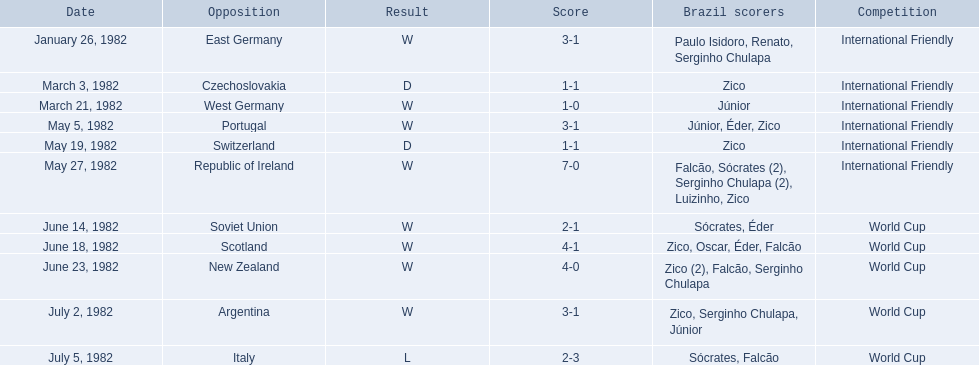Who did brazil play against Soviet Union. Who scored the most goals? Portugal. 